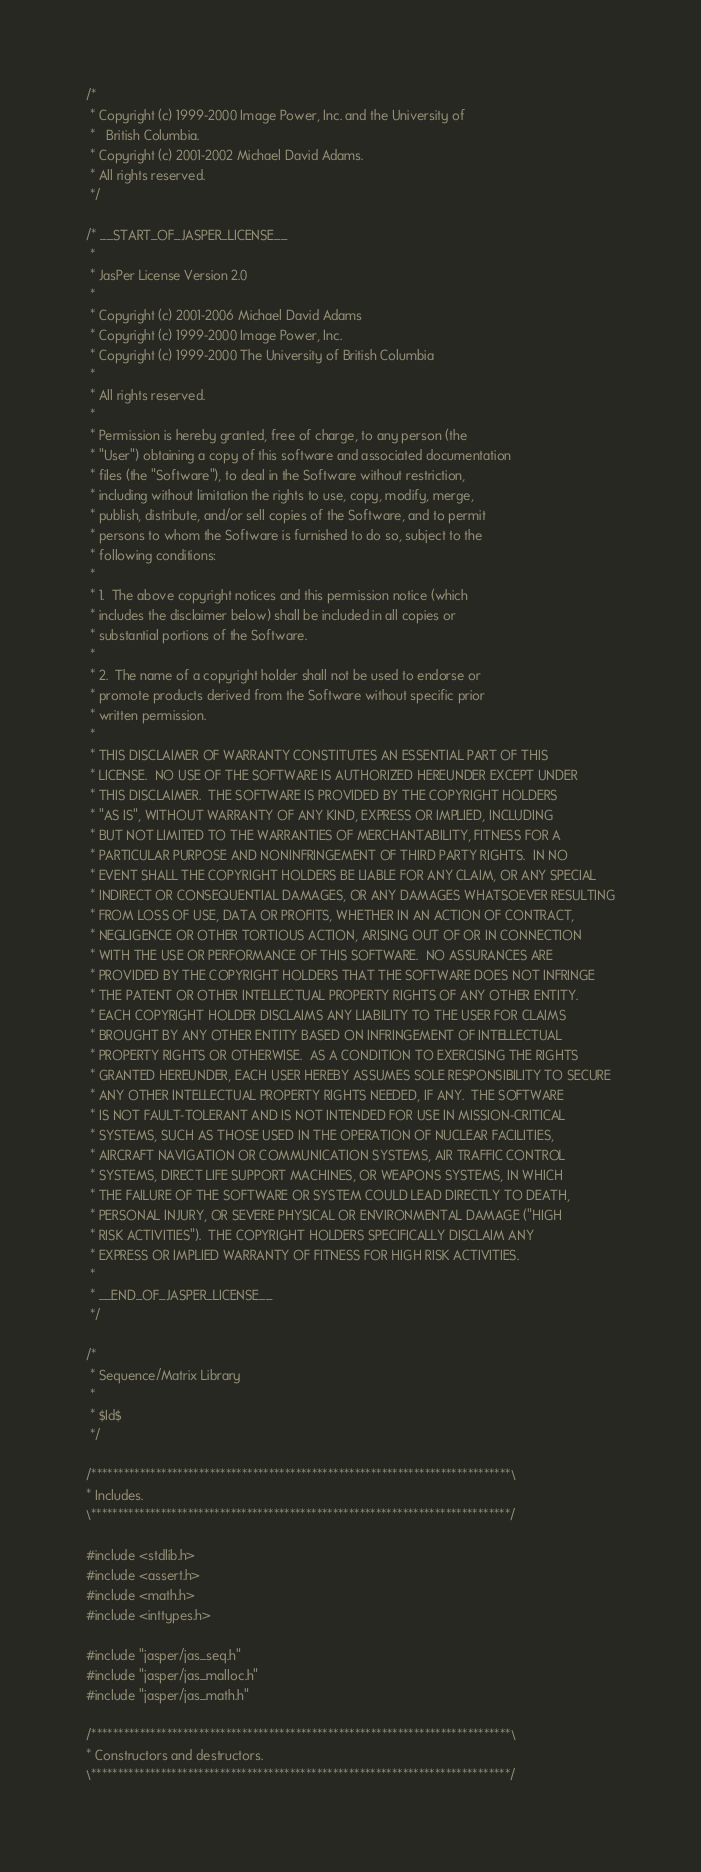<code> <loc_0><loc_0><loc_500><loc_500><_C_>/*
 * Copyright (c) 1999-2000 Image Power, Inc. and the University of
 *   British Columbia.
 * Copyright (c) 2001-2002 Michael David Adams.
 * All rights reserved.
 */

/* __START_OF_JASPER_LICENSE__
 * 
 * JasPer License Version 2.0
 * 
 * Copyright (c) 2001-2006 Michael David Adams
 * Copyright (c) 1999-2000 Image Power, Inc.
 * Copyright (c) 1999-2000 The University of British Columbia
 * 
 * All rights reserved.
 * 
 * Permission is hereby granted, free of charge, to any person (the
 * "User") obtaining a copy of this software and associated documentation
 * files (the "Software"), to deal in the Software without restriction,
 * including without limitation the rights to use, copy, modify, merge,
 * publish, distribute, and/or sell copies of the Software, and to permit
 * persons to whom the Software is furnished to do so, subject to the
 * following conditions:
 * 
 * 1.  The above copyright notices and this permission notice (which
 * includes the disclaimer below) shall be included in all copies or
 * substantial portions of the Software.
 * 
 * 2.  The name of a copyright holder shall not be used to endorse or
 * promote products derived from the Software without specific prior
 * written permission.
 * 
 * THIS DISCLAIMER OF WARRANTY CONSTITUTES AN ESSENTIAL PART OF THIS
 * LICENSE.  NO USE OF THE SOFTWARE IS AUTHORIZED HEREUNDER EXCEPT UNDER
 * THIS DISCLAIMER.  THE SOFTWARE IS PROVIDED BY THE COPYRIGHT HOLDERS
 * "AS IS", WITHOUT WARRANTY OF ANY KIND, EXPRESS OR IMPLIED, INCLUDING
 * BUT NOT LIMITED TO THE WARRANTIES OF MERCHANTABILITY, FITNESS FOR A
 * PARTICULAR PURPOSE AND NONINFRINGEMENT OF THIRD PARTY RIGHTS.  IN NO
 * EVENT SHALL THE COPYRIGHT HOLDERS BE LIABLE FOR ANY CLAIM, OR ANY SPECIAL
 * INDIRECT OR CONSEQUENTIAL DAMAGES, OR ANY DAMAGES WHATSOEVER RESULTING
 * FROM LOSS OF USE, DATA OR PROFITS, WHETHER IN AN ACTION OF CONTRACT,
 * NEGLIGENCE OR OTHER TORTIOUS ACTION, ARISING OUT OF OR IN CONNECTION
 * WITH THE USE OR PERFORMANCE OF THIS SOFTWARE.  NO ASSURANCES ARE
 * PROVIDED BY THE COPYRIGHT HOLDERS THAT THE SOFTWARE DOES NOT INFRINGE
 * THE PATENT OR OTHER INTELLECTUAL PROPERTY RIGHTS OF ANY OTHER ENTITY.
 * EACH COPYRIGHT HOLDER DISCLAIMS ANY LIABILITY TO THE USER FOR CLAIMS
 * BROUGHT BY ANY OTHER ENTITY BASED ON INFRINGEMENT OF INTELLECTUAL
 * PROPERTY RIGHTS OR OTHERWISE.  AS A CONDITION TO EXERCISING THE RIGHTS
 * GRANTED HEREUNDER, EACH USER HEREBY ASSUMES SOLE RESPONSIBILITY TO SECURE
 * ANY OTHER INTELLECTUAL PROPERTY RIGHTS NEEDED, IF ANY.  THE SOFTWARE
 * IS NOT FAULT-TOLERANT AND IS NOT INTENDED FOR USE IN MISSION-CRITICAL
 * SYSTEMS, SUCH AS THOSE USED IN THE OPERATION OF NUCLEAR FACILITIES,
 * AIRCRAFT NAVIGATION OR COMMUNICATION SYSTEMS, AIR TRAFFIC CONTROL
 * SYSTEMS, DIRECT LIFE SUPPORT MACHINES, OR WEAPONS SYSTEMS, IN WHICH
 * THE FAILURE OF THE SOFTWARE OR SYSTEM COULD LEAD DIRECTLY TO DEATH,
 * PERSONAL INJURY, OR SEVERE PHYSICAL OR ENVIRONMENTAL DAMAGE ("HIGH
 * RISK ACTIVITIES").  THE COPYRIGHT HOLDERS SPECIFICALLY DISCLAIM ANY
 * EXPRESS OR IMPLIED WARRANTY OF FITNESS FOR HIGH RISK ACTIVITIES.
 * 
 * __END_OF_JASPER_LICENSE__
 */

/*
 * Sequence/Matrix Library
 *
 * $Id$
 */

/******************************************************************************\
* Includes.
\******************************************************************************/

#include <stdlib.h>
#include <assert.h>
#include <math.h>
#include <inttypes.h>

#include "jasper/jas_seq.h"
#include "jasper/jas_malloc.h"
#include "jasper/jas_math.h"

/******************************************************************************\
* Constructors and destructors.
\******************************************************************************/
</code> 